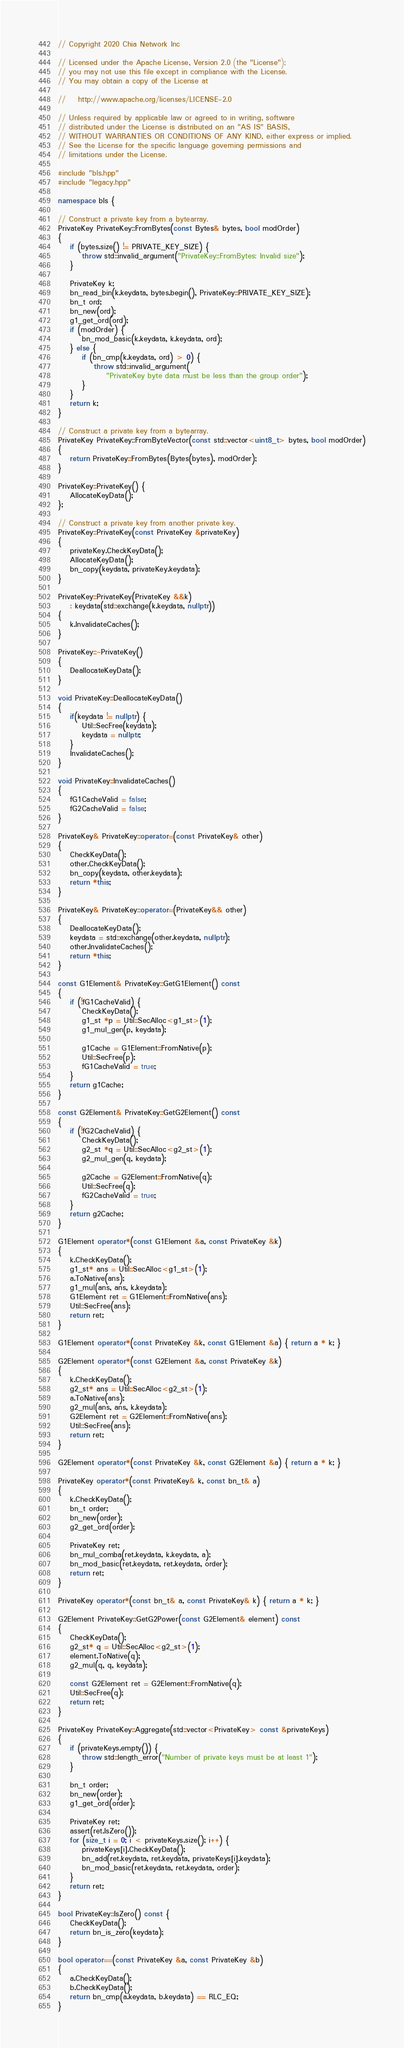Convert code to text. <code><loc_0><loc_0><loc_500><loc_500><_C++_>// Copyright 2020 Chia Network Inc

// Licensed under the Apache License, Version 2.0 (the "License");
// you may not use this file except in compliance with the License.
// You may obtain a copy of the License at

//    http://www.apache.org/licenses/LICENSE-2.0

// Unless required by applicable law or agreed to in writing, software
// distributed under the License is distributed on an "AS IS" BASIS,
// WITHOUT WARRANTIES OR CONDITIONS OF ANY KIND, either express or implied.
// See the License for the specific language governing permissions and
// limitations under the License.

#include "bls.hpp"
#include "legacy.hpp"

namespace bls {

// Construct a private key from a bytearray.
PrivateKey PrivateKey::FromBytes(const Bytes& bytes, bool modOrder)
{
    if (bytes.size() != PRIVATE_KEY_SIZE) {
        throw std::invalid_argument("PrivateKey::FromBytes: Invalid size");
    }

    PrivateKey k;
    bn_read_bin(k.keydata, bytes.begin(), PrivateKey::PRIVATE_KEY_SIZE);
    bn_t ord;
    bn_new(ord);
    g1_get_ord(ord);
    if (modOrder) {
        bn_mod_basic(k.keydata, k.keydata, ord);
    } else {
        if (bn_cmp(k.keydata, ord) > 0) {
            throw std::invalid_argument(
                "PrivateKey byte data must be less than the group order");
        }
    }
    return k;
}

// Construct a private key from a bytearray.
PrivateKey PrivateKey::FromByteVector(const std::vector<uint8_t> bytes, bool modOrder)
{
    return PrivateKey::FromBytes(Bytes(bytes), modOrder);
}

PrivateKey::PrivateKey() {
    AllocateKeyData();
};

// Construct a private key from another private key.
PrivateKey::PrivateKey(const PrivateKey &privateKey)
{
    privateKey.CheckKeyData();
    AllocateKeyData();
    bn_copy(keydata, privateKey.keydata);
}

PrivateKey::PrivateKey(PrivateKey &&k)
    : keydata(std::exchange(k.keydata, nullptr))
{
    k.InvalidateCaches();
}

PrivateKey::~PrivateKey()
{
    DeallocateKeyData();
}

void PrivateKey::DeallocateKeyData()
{
    if(keydata != nullptr) {
        Util::SecFree(keydata);
        keydata = nullptr;
    }
    InvalidateCaches();
}

void PrivateKey::InvalidateCaches()
{
    fG1CacheValid = false;
    fG2CacheValid = false;
}

PrivateKey& PrivateKey::operator=(const PrivateKey& other)
{
    CheckKeyData();
    other.CheckKeyData();
    bn_copy(keydata, other.keydata);
    return *this;
}

PrivateKey& PrivateKey::operator=(PrivateKey&& other)
{
    DeallocateKeyData();
    keydata = std::exchange(other.keydata, nullptr);
    other.InvalidateCaches();
    return *this;
}

const G1Element& PrivateKey::GetG1Element() const
{
    if (!fG1CacheValid) {
        CheckKeyData();
        g1_st *p = Util::SecAlloc<g1_st>(1);
        g1_mul_gen(p, keydata);

        g1Cache = G1Element::FromNative(p);
        Util::SecFree(p);
        fG1CacheValid = true;
    }
    return g1Cache;
}

const G2Element& PrivateKey::GetG2Element() const
{
    if (!fG2CacheValid) {
        CheckKeyData();
        g2_st *q = Util::SecAlloc<g2_st>(1);
        g2_mul_gen(q, keydata);

        g2Cache = G2Element::FromNative(q);
        Util::SecFree(q);
        fG2CacheValid = true;
    }
    return g2Cache;
}

G1Element operator*(const G1Element &a, const PrivateKey &k)
{
    k.CheckKeyData();
    g1_st* ans = Util::SecAlloc<g1_st>(1);
    a.ToNative(ans);
    g1_mul(ans, ans, k.keydata);
    G1Element ret = G1Element::FromNative(ans);
    Util::SecFree(ans);
    return ret;
}

G1Element operator*(const PrivateKey &k, const G1Element &a) { return a * k; }

G2Element operator*(const G2Element &a, const PrivateKey &k)
{
    k.CheckKeyData();
    g2_st* ans = Util::SecAlloc<g2_st>(1);
    a.ToNative(ans);
    g2_mul(ans, ans, k.keydata);
    G2Element ret = G2Element::FromNative(ans);
    Util::SecFree(ans);
    return ret;
}

G2Element operator*(const PrivateKey &k, const G2Element &a) { return a * k; }

PrivateKey operator*(const PrivateKey& k, const bn_t& a)
{
    k.CheckKeyData();
    bn_t order;
    bn_new(order);
    g2_get_ord(order);

    PrivateKey ret;
    bn_mul_comba(ret.keydata, k.keydata, a);
    bn_mod_basic(ret.keydata, ret.keydata, order);
    return ret;
}

PrivateKey operator*(const bn_t& a, const PrivateKey& k) { return a * k; }

G2Element PrivateKey::GetG2Power(const G2Element& element) const
{
    CheckKeyData();
    g2_st* q = Util::SecAlloc<g2_st>(1);
    element.ToNative(q);
    g2_mul(q, q, keydata);

    const G2Element ret = G2Element::FromNative(q);
    Util::SecFree(q);
    return ret;
}

PrivateKey PrivateKey::Aggregate(std::vector<PrivateKey> const &privateKeys)
{
    if (privateKeys.empty()) {
        throw std::length_error("Number of private keys must be at least 1");
    }

    bn_t order;
    bn_new(order);
    g1_get_ord(order);

    PrivateKey ret;
    assert(ret.IsZero());
    for (size_t i = 0; i < privateKeys.size(); i++) {
        privateKeys[i].CheckKeyData();
        bn_add(ret.keydata, ret.keydata, privateKeys[i].keydata);
        bn_mod_basic(ret.keydata, ret.keydata, order);
    }
    return ret;
}

bool PrivateKey::IsZero() const {
    CheckKeyData();
    return bn_is_zero(keydata);
}

bool operator==(const PrivateKey &a, const PrivateKey &b)
{
    a.CheckKeyData();
    b.CheckKeyData();
    return bn_cmp(a.keydata, b.keydata) == RLC_EQ;
}
</code> 